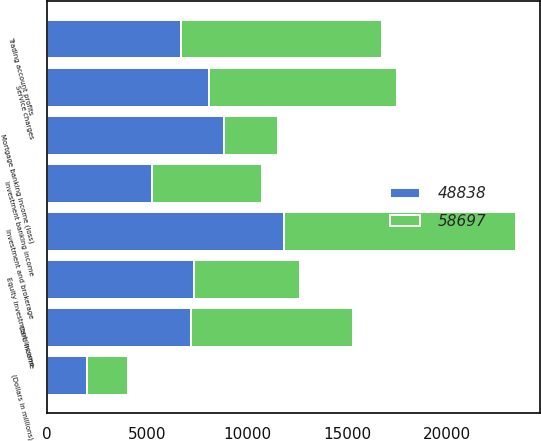Convert chart to OTSL. <chart><loc_0><loc_0><loc_500><loc_500><stacked_bar_chart><ecel><fcel>(Dollars in millions)<fcel>Card income<fcel>Service charges<fcel>Investment and brokerage<fcel>Investment banking income<fcel>Equity investment income<fcel>Trading account profits<fcel>Mortgage banking income (loss)<nl><fcel>48838<fcel>2011<fcel>7184<fcel>8094<fcel>11826<fcel>5217<fcel>7360<fcel>6697<fcel>8830<nl><fcel>58697<fcel>2010<fcel>8108<fcel>9390<fcel>11622<fcel>5520<fcel>5260<fcel>10054<fcel>2734<nl></chart> 